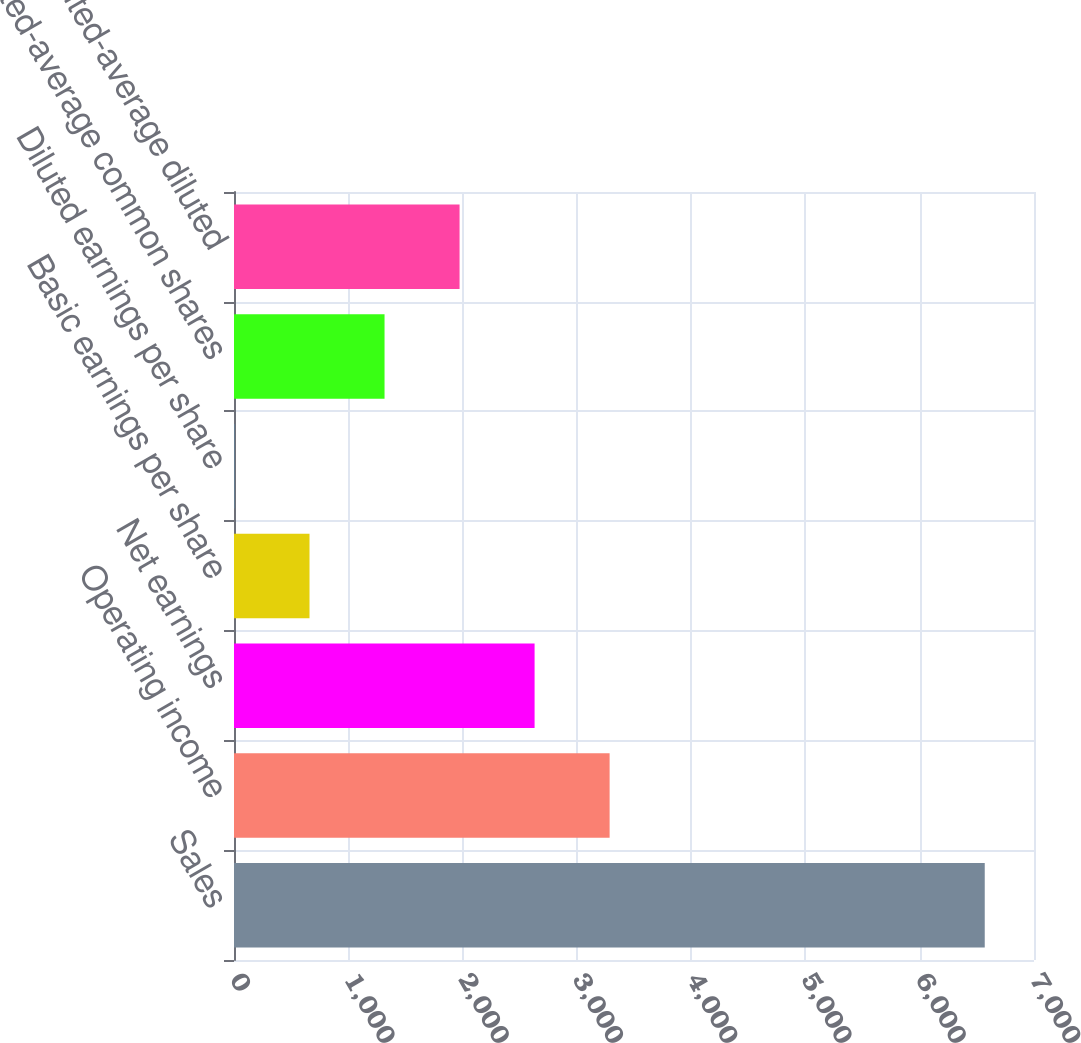<chart> <loc_0><loc_0><loc_500><loc_500><bar_chart><fcel>Sales<fcel>Operating income<fcel>Net earnings<fcel>Basic earnings per share<fcel>Diluted earnings per share<fcel>Weighted-average common shares<fcel>Weighted-average diluted<nl><fcel>6569<fcel>3286.63<fcel>2630.16<fcel>660.75<fcel>4.28<fcel>1317.22<fcel>1973.69<nl></chart> 